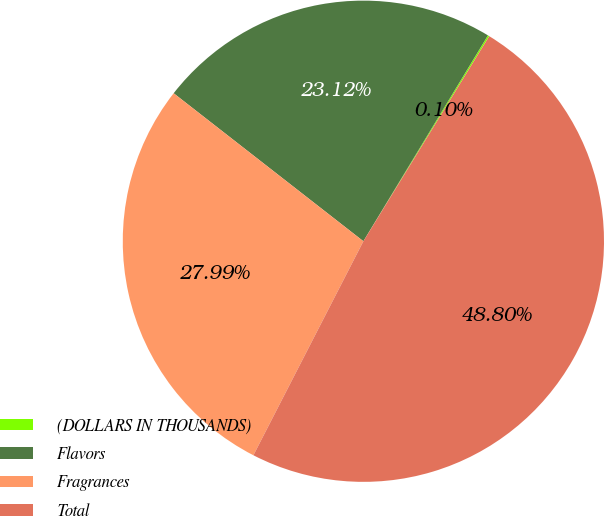Convert chart to OTSL. <chart><loc_0><loc_0><loc_500><loc_500><pie_chart><fcel>(DOLLARS IN THOUSANDS)<fcel>Flavors<fcel>Fragrances<fcel>Total<nl><fcel>0.1%<fcel>23.12%<fcel>27.99%<fcel>48.8%<nl></chart> 